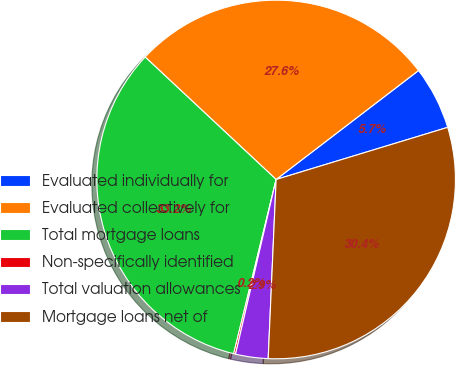Convert chart to OTSL. <chart><loc_0><loc_0><loc_500><loc_500><pie_chart><fcel>Evaluated individually for<fcel>Evaluated collectively for<fcel>Total mortgage loans<fcel>Non-specifically identified<fcel>Total valuation allowances<fcel>Mortgage loans net of<nl><fcel>5.7%<fcel>27.64%<fcel>33.16%<fcel>0.17%<fcel>2.93%<fcel>30.4%<nl></chart> 